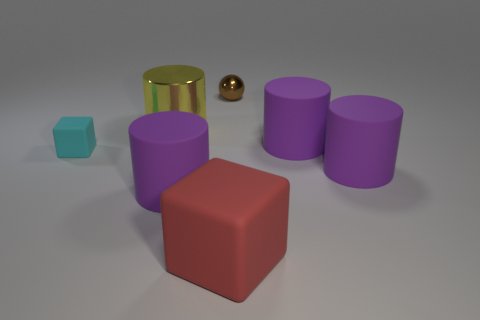How many purple cylinders must be subtracted to get 1 purple cylinders? 2 Subtract all yellow cubes. How many purple cylinders are left? 3 Subtract 1 cylinders. How many cylinders are left? 3 Add 2 tiny cyan rubber blocks. How many objects exist? 9 Subtract all blocks. How many objects are left? 5 Subtract 1 brown spheres. How many objects are left? 6 Subtract all matte blocks. Subtract all yellow things. How many objects are left? 4 Add 2 big yellow cylinders. How many big yellow cylinders are left? 3 Add 4 tiny yellow cylinders. How many tiny yellow cylinders exist? 4 